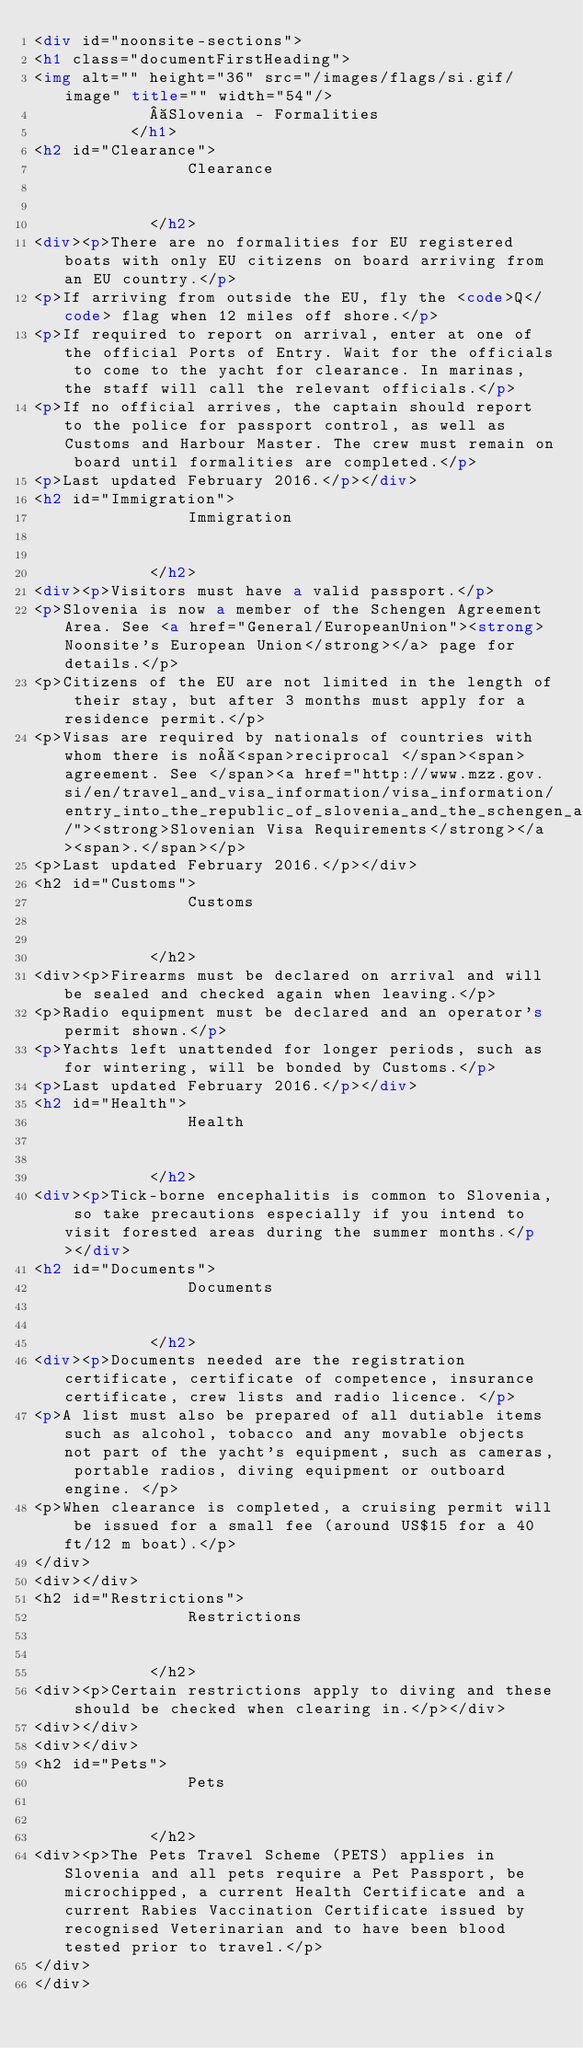<code> <loc_0><loc_0><loc_500><loc_500><_HTML_><div id="noonsite-sections">
<h1 class="documentFirstHeading">
<img alt="" height="36" src="/images/flags/si.gif/image" title="" width="54"/>	
	           Slovenia - Formalities
	        </h1>
<h2 id="Clearance">
                Clearance
                
                
            </h2>
<div><p>There are no formalities for EU registered boats with only EU citizens on board arriving from an EU country.</p>
<p>If arriving from outside the EU, fly the <code>Q</code> flag when 12 miles off shore.</p>
<p>If required to report on arrival, enter at one of the official Ports of Entry. Wait for the officials to come to the yacht for clearance. In marinas, the staff will call the relevant officials.</p>
<p>If no official arrives, the captain should report to the police for passport control, as well as Customs and Harbour Master. The crew must remain on board until formalities are completed.</p>
<p>Last updated February 2016.</p></div>
<h2 id="Immigration">
                Immigration
                
                
            </h2>
<div><p>Visitors must have a valid passport.</p>
<p>Slovenia is now a member of the Schengen Agreement Area. See <a href="General/EuropeanUnion"><strong>Noonsite's European Union</strong></a> page for details.</p>
<p>Citizens of the EU are not limited in the length of their stay, but after 3 months must apply for a residence permit.</p>
<p>Visas are required by nationals of countries with whom there is no <span>reciprocal </span><span>agreement. See </span><a href="http://www.mzz.gov.si/en/travel_and_visa_information/visa_information/entry_into_the_republic_of_slovenia_and_the_schengen_area/"><strong>Slovenian Visa Requirements</strong></a><span>.</span></p>
<p>Last updated February 2016.</p></div>
<h2 id="Customs">
                Customs
                
                
            </h2>
<div><p>Firearms must be declared on arrival and will be sealed and checked again when leaving.</p>
<p>Radio equipment must be declared and an operator's permit shown.</p>
<p>Yachts left unattended for longer periods, such as for wintering, will be bonded by Customs.</p>
<p>Last updated February 2016.</p></div>
<h2 id="Health">
                Health
                
                
            </h2>
<div><p>Tick-borne encephalitis is common to Slovenia, so take precautions especially if you intend to visit forested areas during the summer months.</p></div>
<h2 id="Documents">
                Documents
                
                
            </h2>
<div><p>Documents needed are the registration certificate, certificate of competence, insurance certificate, crew lists and radio licence. </p>
<p>A list must also be prepared of all dutiable items such as alcohol, tobacco and any movable objects not part of the yacht's equipment, such as cameras, portable radios, diving equipment or outboard engine. </p>
<p>When clearance is completed, a cruising permit will be issued for a small fee (around US$15 for a 40 ft/12 m boat).</p>
</div>
<div></div>
<h2 id="Restrictions">
                Restrictions
                
                
            </h2>
<div><p>Certain restrictions apply to diving and these should be checked when clearing in.</p></div>
<div></div>
<div></div>
<h2 id="Pets">
                Pets
                
                
            </h2>
<div><p>The Pets Travel Scheme (PETS) applies in Slovenia and all pets require a Pet Passport, be microchipped, a current Health Certificate and a current Rabies Vaccination Certificate issued by recognised Veterinarian and to have been blood tested prior to travel.</p>
</div>
</div></code> 